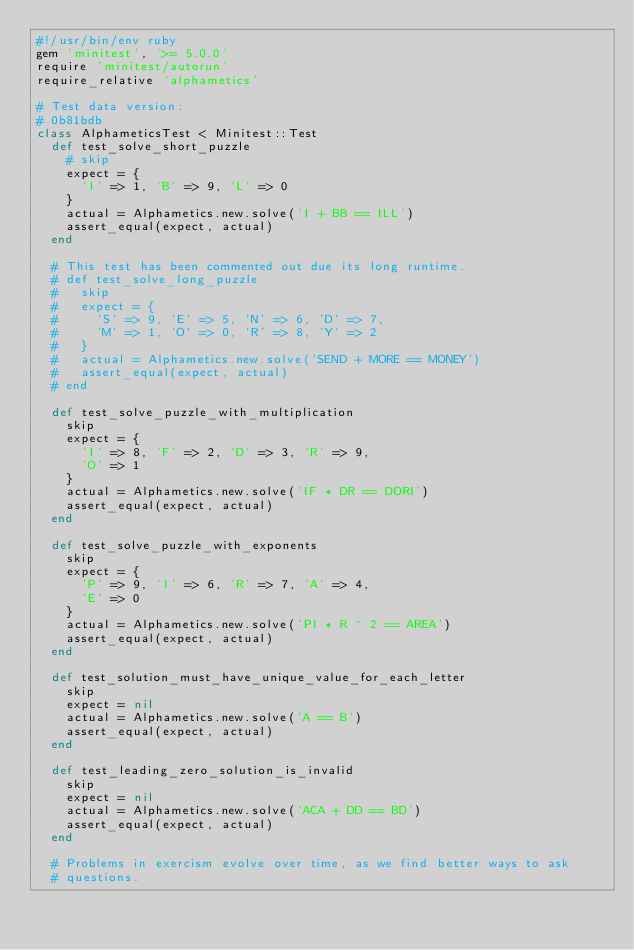<code> <loc_0><loc_0><loc_500><loc_500><_Ruby_>#!/usr/bin/env ruby
gem 'minitest', '>= 5.0.0'
require 'minitest/autorun'
require_relative 'alphametics'

# Test data version:
# 0b81bdb
class AlphameticsTest < Minitest::Test
  def test_solve_short_puzzle
    # skip
    expect = {
      'I' => 1, 'B' => 9, 'L' => 0
    }
    actual = Alphametics.new.solve('I + BB == ILL')
    assert_equal(expect, actual)
  end

  # This test has been commented out due its long runtime.
  # def test_solve_long_puzzle
  #   skip
  #   expect = {
  #     'S' => 9, 'E' => 5, 'N' => 6, 'D' => 7,
  #     'M' => 1, 'O' => 0, 'R' => 8, 'Y' => 2
  #   }
  #   actual = Alphametics.new.solve('SEND + MORE == MONEY')
  #   assert_equal(expect, actual)
  # end

  def test_solve_puzzle_with_multiplication
    skip
    expect = {
      'I' => 8, 'F' => 2, 'D' => 3, 'R' => 9,
      'O' => 1
    }
    actual = Alphametics.new.solve('IF * DR == DORI')
    assert_equal(expect, actual)
  end

  def test_solve_puzzle_with_exponents
    skip
    expect = {
      'P' => 9, 'I' => 6, 'R' => 7, 'A' => 4,
      'E' => 0
    }
    actual = Alphametics.new.solve('PI * R ^ 2 == AREA')
    assert_equal(expect, actual)
  end

  def test_solution_must_have_unique_value_for_each_letter
    skip
    expect = nil
    actual = Alphametics.new.solve('A == B')
    assert_equal(expect, actual)
  end

  def test_leading_zero_solution_is_invalid
    skip
    expect = nil
    actual = Alphametics.new.solve('ACA + DD == BD')
    assert_equal(expect, actual)
  end

  # Problems in exercism evolve over time, as we find better ways to ask
  # questions.</code> 